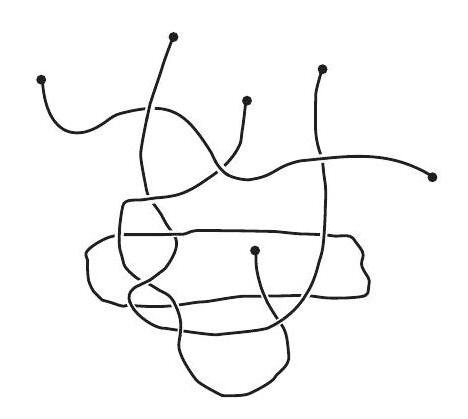What artistic interpretations can be drawn from this image? This image may evoke ideas of chaos and connectivity, with the tangled strings representing how various elements in life or nature can interweave in complex and unexpected ways. It might also be seen as a metaphor for the interconnectedness of life or the underlying order within apparent randomness. 